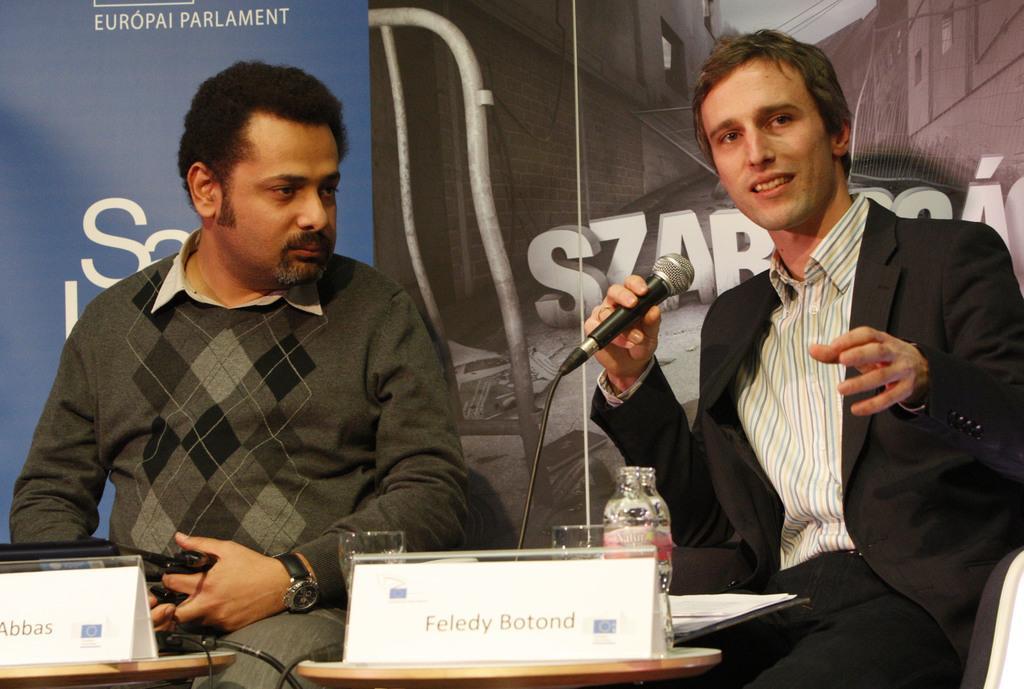Could you give a brief overview of what you see in this image? Two persons are sitting there and one person wearing a black coat is holding a mic and smiling. And another person is wearing a watch. And in front of them there is a small table and two name plates are there. On the table there are bottles and glasses. Behind them there are some banners. 